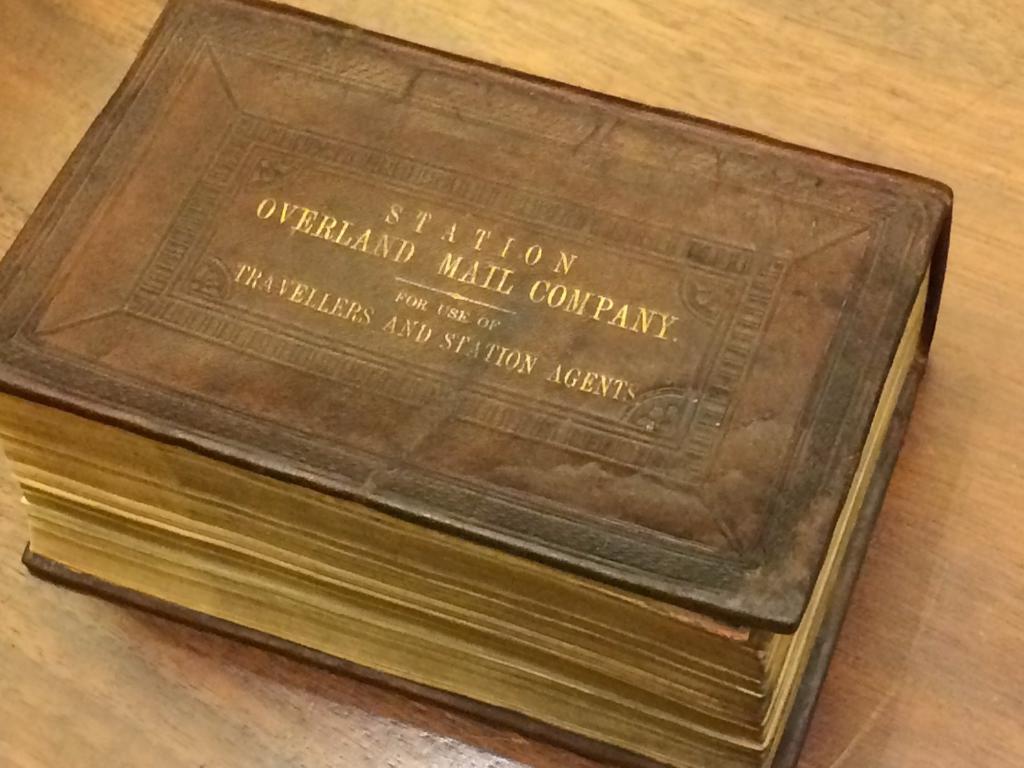Who used this?
Give a very brief answer. Travellers and station agents. 